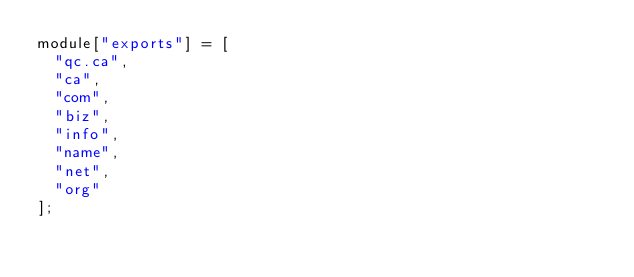<code> <loc_0><loc_0><loc_500><loc_500><_JavaScript_>module["exports"] = [
  "qc.ca",
  "ca",
  "com",
  "biz",
  "info",
  "name",
  "net",
  "org"
];
</code> 